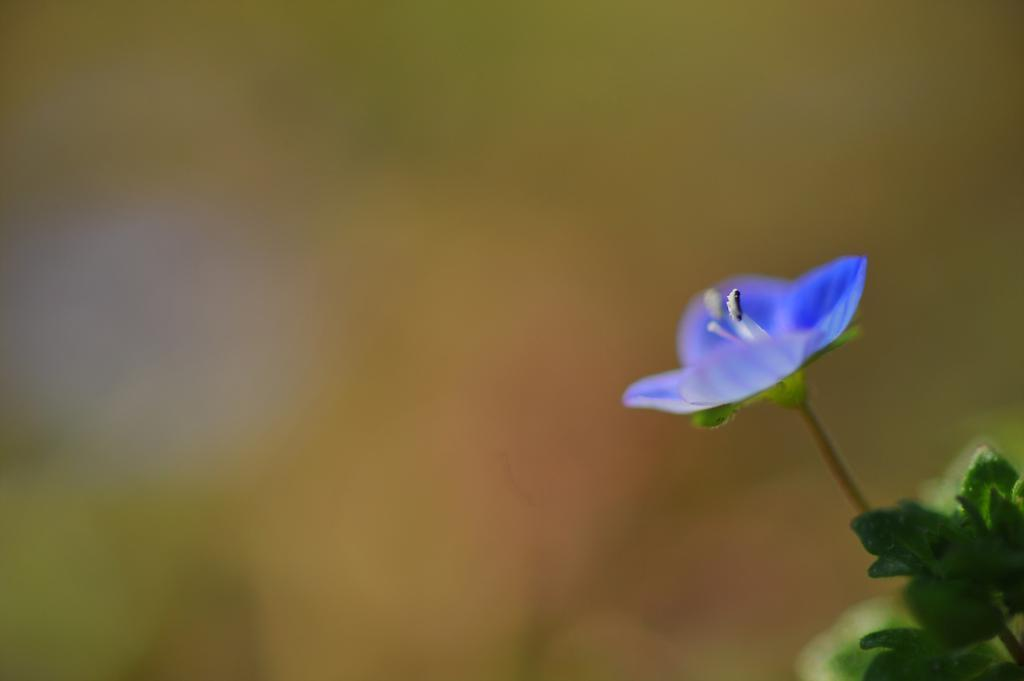What type of flower is in the image? There is a violet flower in the image. What other plant elements are visible in the image? There are green leaves in the image. Where are the green leaves located in the image? The green leaves are on the right side of the image. How would you describe the background of the image? The background of the image is blurry. What sound does the stick make when it is being used to rake the leaves in the image? There is no stick or raking activity present in the image; it only features a violet flower and green leaves. 